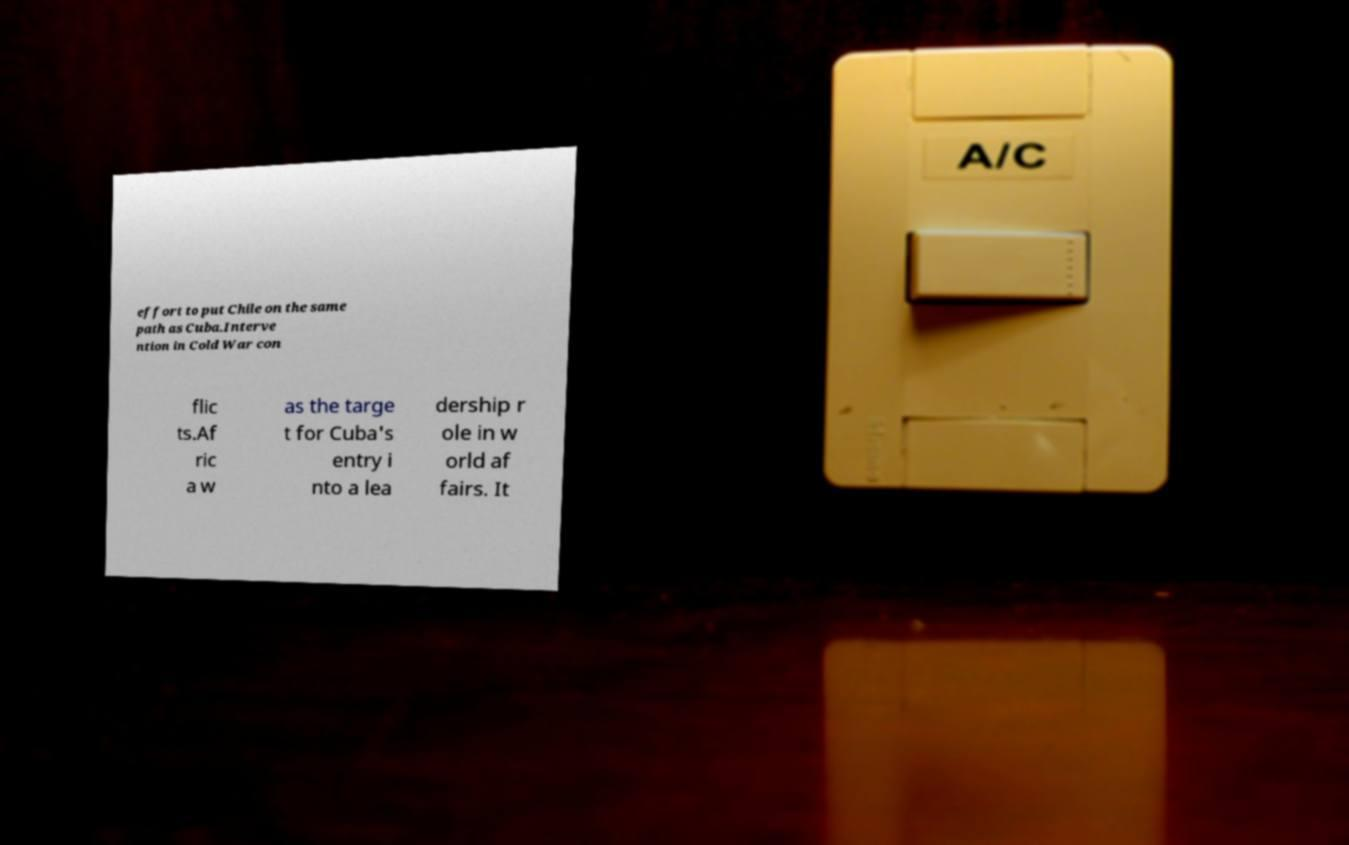I need the written content from this picture converted into text. Can you do that? effort to put Chile on the same path as Cuba.Interve ntion in Cold War con flic ts.Af ric a w as the targe t for Cuba's entry i nto a lea dership r ole in w orld af fairs. It 